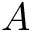<formula> <loc_0><loc_0><loc_500><loc_500>A</formula> 